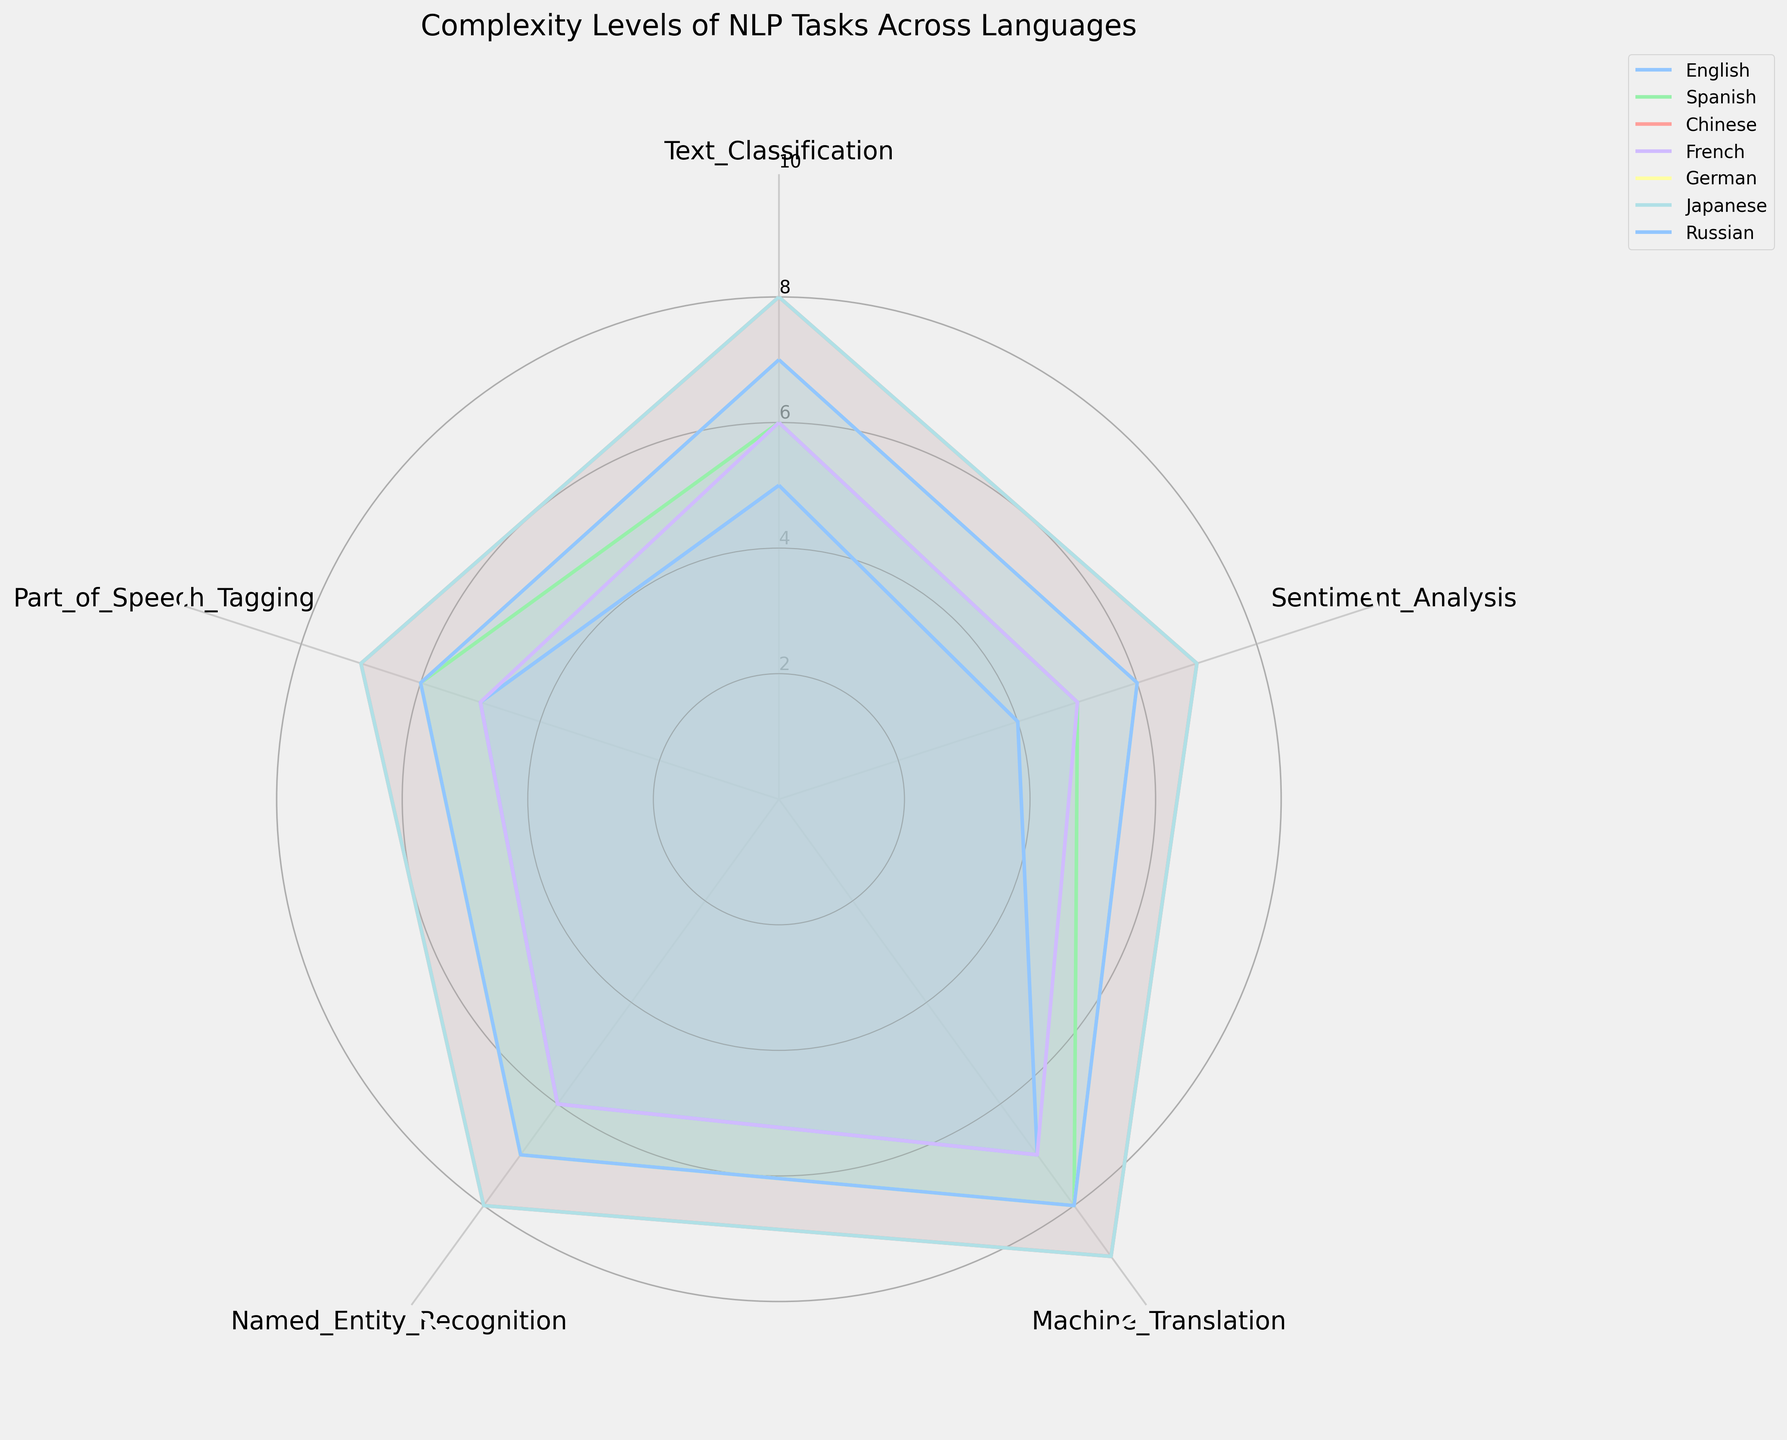What is the title of the chart? Look at the top of the chart where the title is usually placed.
Answer: Complexity Levels of NLP Tasks Across Languages Which language has the highest complexity for Machine Translation? Refer to the "Machine Translation" category in the chart and find the language with the highest point on the radial axis for that category.
Answer: Chinese and Japanese Which Natural Language Processing (NLP) task shows the highest average complexity across all languages? Sum the complexity levels of each task for all languages and then divide by the number of languages to get the average. Compare these averages.
Answer: Machine Translation Is the complexity level for Sentiment Analysis higher in English or Russian? Compare the points corresponding to "Sentiment Analysis" for English and Russian.
Answer: Russian Rank the languages based on the complexity for Named Entity Recognition from highest to lowest. Look at the "Named Entity Recognition" segment for each language and list them in descending order based on their point on the radial axis.
Answer: Chinese = Japanese > German = Russian > Spanish > English = French What are the y-axis tick labels used in the chart? Identify the labels on the concentric circles that represent the y-axis.
Answer: 2, 4, 6, 8, 10 Which language has the most consistent complexity levels across all NLP tasks? For each language, examine how similar the plotted points are across all categories. The language with the smallest variation in complexity levels is the most consistent.
Answer: English and French Calculate the difference in complexity for Part of Speech (POS) Tagging between Chinese and Spanish. Subtract the value of POS Tagging for Spanish from that of Chinese.
Answer: 1 How many different languages are being compared in the chart? Count the number of unique language labels in the chart's legend.
Answer: 7 For which task do English and French exhibit the same complexity level? Look at each task segment and see where the points for English and French are at the same level.
Answer: Text Classification, Machine Translation, Named Entity Recognition, Part of Speech Tagging 